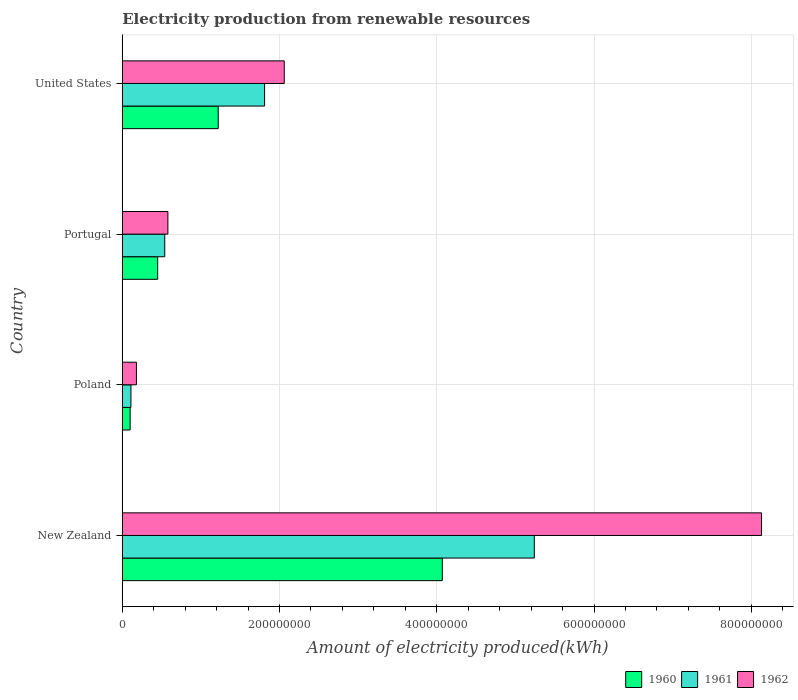How many different coloured bars are there?
Ensure brevity in your answer.  3. How many bars are there on the 4th tick from the bottom?
Your answer should be compact. 3. What is the label of the 3rd group of bars from the top?
Provide a short and direct response. Poland. What is the amount of electricity produced in 1961 in New Zealand?
Give a very brief answer. 5.24e+08. Across all countries, what is the maximum amount of electricity produced in 1960?
Your answer should be very brief. 4.07e+08. Across all countries, what is the minimum amount of electricity produced in 1962?
Offer a very short reply. 1.80e+07. In which country was the amount of electricity produced in 1961 maximum?
Offer a very short reply. New Zealand. What is the total amount of electricity produced in 1960 in the graph?
Provide a short and direct response. 5.84e+08. What is the difference between the amount of electricity produced in 1960 in New Zealand and that in United States?
Make the answer very short. 2.85e+08. What is the difference between the amount of electricity produced in 1962 in Poland and the amount of electricity produced in 1961 in United States?
Keep it short and to the point. -1.63e+08. What is the average amount of electricity produced in 1960 per country?
Make the answer very short. 1.46e+08. What is the difference between the amount of electricity produced in 1961 and amount of electricity produced in 1960 in Portugal?
Offer a terse response. 9.00e+06. What is the ratio of the amount of electricity produced in 1962 in Poland to that in Portugal?
Offer a terse response. 0.31. What is the difference between the highest and the second highest amount of electricity produced in 1962?
Provide a succinct answer. 6.07e+08. What is the difference between the highest and the lowest amount of electricity produced in 1962?
Your answer should be very brief. 7.95e+08. In how many countries, is the amount of electricity produced in 1960 greater than the average amount of electricity produced in 1960 taken over all countries?
Provide a short and direct response. 1. Is the sum of the amount of electricity produced in 1961 in New Zealand and Portugal greater than the maximum amount of electricity produced in 1960 across all countries?
Keep it short and to the point. Yes. What does the 3rd bar from the bottom in United States represents?
Give a very brief answer. 1962. Are all the bars in the graph horizontal?
Offer a terse response. Yes. Does the graph contain any zero values?
Offer a terse response. No. Where does the legend appear in the graph?
Offer a terse response. Bottom right. How many legend labels are there?
Keep it short and to the point. 3. What is the title of the graph?
Ensure brevity in your answer.  Electricity production from renewable resources. Does "2008" appear as one of the legend labels in the graph?
Keep it short and to the point. No. What is the label or title of the X-axis?
Your answer should be very brief. Amount of electricity produced(kWh). What is the label or title of the Y-axis?
Make the answer very short. Country. What is the Amount of electricity produced(kWh) of 1960 in New Zealand?
Your answer should be very brief. 4.07e+08. What is the Amount of electricity produced(kWh) in 1961 in New Zealand?
Provide a succinct answer. 5.24e+08. What is the Amount of electricity produced(kWh) of 1962 in New Zealand?
Offer a very short reply. 8.13e+08. What is the Amount of electricity produced(kWh) of 1961 in Poland?
Make the answer very short. 1.10e+07. What is the Amount of electricity produced(kWh) of 1962 in Poland?
Keep it short and to the point. 1.80e+07. What is the Amount of electricity produced(kWh) in 1960 in Portugal?
Provide a short and direct response. 4.50e+07. What is the Amount of electricity produced(kWh) of 1961 in Portugal?
Give a very brief answer. 5.40e+07. What is the Amount of electricity produced(kWh) in 1962 in Portugal?
Ensure brevity in your answer.  5.80e+07. What is the Amount of electricity produced(kWh) of 1960 in United States?
Your answer should be compact. 1.22e+08. What is the Amount of electricity produced(kWh) in 1961 in United States?
Give a very brief answer. 1.81e+08. What is the Amount of electricity produced(kWh) in 1962 in United States?
Offer a very short reply. 2.06e+08. Across all countries, what is the maximum Amount of electricity produced(kWh) in 1960?
Offer a very short reply. 4.07e+08. Across all countries, what is the maximum Amount of electricity produced(kWh) in 1961?
Your answer should be compact. 5.24e+08. Across all countries, what is the maximum Amount of electricity produced(kWh) of 1962?
Ensure brevity in your answer.  8.13e+08. Across all countries, what is the minimum Amount of electricity produced(kWh) of 1961?
Offer a very short reply. 1.10e+07. Across all countries, what is the minimum Amount of electricity produced(kWh) of 1962?
Offer a terse response. 1.80e+07. What is the total Amount of electricity produced(kWh) in 1960 in the graph?
Give a very brief answer. 5.84e+08. What is the total Amount of electricity produced(kWh) of 1961 in the graph?
Ensure brevity in your answer.  7.70e+08. What is the total Amount of electricity produced(kWh) of 1962 in the graph?
Ensure brevity in your answer.  1.10e+09. What is the difference between the Amount of electricity produced(kWh) of 1960 in New Zealand and that in Poland?
Your response must be concise. 3.97e+08. What is the difference between the Amount of electricity produced(kWh) of 1961 in New Zealand and that in Poland?
Your answer should be compact. 5.13e+08. What is the difference between the Amount of electricity produced(kWh) in 1962 in New Zealand and that in Poland?
Ensure brevity in your answer.  7.95e+08. What is the difference between the Amount of electricity produced(kWh) of 1960 in New Zealand and that in Portugal?
Offer a very short reply. 3.62e+08. What is the difference between the Amount of electricity produced(kWh) of 1961 in New Zealand and that in Portugal?
Give a very brief answer. 4.70e+08. What is the difference between the Amount of electricity produced(kWh) of 1962 in New Zealand and that in Portugal?
Make the answer very short. 7.55e+08. What is the difference between the Amount of electricity produced(kWh) in 1960 in New Zealand and that in United States?
Give a very brief answer. 2.85e+08. What is the difference between the Amount of electricity produced(kWh) of 1961 in New Zealand and that in United States?
Your answer should be very brief. 3.43e+08. What is the difference between the Amount of electricity produced(kWh) in 1962 in New Zealand and that in United States?
Keep it short and to the point. 6.07e+08. What is the difference between the Amount of electricity produced(kWh) of 1960 in Poland and that in Portugal?
Your answer should be compact. -3.50e+07. What is the difference between the Amount of electricity produced(kWh) in 1961 in Poland and that in Portugal?
Ensure brevity in your answer.  -4.30e+07. What is the difference between the Amount of electricity produced(kWh) in 1962 in Poland and that in Portugal?
Give a very brief answer. -4.00e+07. What is the difference between the Amount of electricity produced(kWh) in 1960 in Poland and that in United States?
Offer a terse response. -1.12e+08. What is the difference between the Amount of electricity produced(kWh) of 1961 in Poland and that in United States?
Offer a very short reply. -1.70e+08. What is the difference between the Amount of electricity produced(kWh) of 1962 in Poland and that in United States?
Ensure brevity in your answer.  -1.88e+08. What is the difference between the Amount of electricity produced(kWh) of 1960 in Portugal and that in United States?
Your response must be concise. -7.70e+07. What is the difference between the Amount of electricity produced(kWh) in 1961 in Portugal and that in United States?
Keep it short and to the point. -1.27e+08. What is the difference between the Amount of electricity produced(kWh) of 1962 in Portugal and that in United States?
Provide a succinct answer. -1.48e+08. What is the difference between the Amount of electricity produced(kWh) of 1960 in New Zealand and the Amount of electricity produced(kWh) of 1961 in Poland?
Ensure brevity in your answer.  3.96e+08. What is the difference between the Amount of electricity produced(kWh) of 1960 in New Zealand and the Amount of electricity produced(kWh) of 1962 in Poland?
Your answer should be compact. 3.89e+08. What is the difference between the Amount of electricity produced(kWh) of 1961 in New Zealand and the Amount of electricity produced(kWh) of 1962 in Poland?
Provide a short and direct response. 5.06e+08. What is the difference between the Amount of electricity produced(kWh) in 1960 in New Zealand and the Amount of electricity produced(kWh) in 1961 in Portugal?
Provide a short and direct response. 3.53e+08. What is the difference between the Amount of electricity produced(kWh) in 1960 in New Zealand and the Amount of electricity produced(kWh) in 1962 in Portugal?
Offer a very short reply. 3.49e+08. What is the difference between the Amount of electricity produced(kWh) in 1961 in New Zealand and the Amount of electricity produced(kWh) in 1962 in Portugal?
Provide a short and direct response. 4.66e+08. What is the difference between the Amount of electricity produced(kWh) in 1960 in New Zealand and the Amount of electricity produced(kWh) in 1961 in United States?
Give a very brief answer. 2.26e+08. What is the difference between the Amount of electricity produced(kWh) of 1960 in New Zealand and the Amount of electricity produced(kWh) of 1962 in United States?
Provide a succinct answer. 2.01e+08. What is the difference between the Amount of electricity produced(kWh) of 1961 in New Zealand and the Amount of electricity produced(kWh) of 1962 in United States?
Your answer should be very brief. 3.18e+08. What is the difference between the Amount of electricity produced(kWh) in 1960 in Poland and the Amount of electricity produced(kWh) in 1961 in Portugal?
Ensure brevity in your answer.  -4.40e+07. What is the difference between the Amount of electricity produced(kWh) in 1960 in Poland and the Amount of electricity produced(kWh) in 1962 in Portugal?
Your response must be concise. -4.80e+07. What is the difference between the Amount of electricity produced(kWh) in 1961 in Poland and the Amount of electricity produced(kWh) in 1962 in Portugal?
Offer a very short reply. -4.70e+07. What is the difference between the Amount of electricity produced(kWh) in 1960 in Poland and the Amount of electricity produced(kWh) in 1961 in United States?
Offer a terse response. -1.71e+08. What is the difference between the Amount of electricity produced(kWh) in 1960 in Poland and the Amount of electricity produced(kWh) in 1962 in United States?
Keep it short and to the point. -1.96e+08. What is the difference between the Amount of electricity produced(kWh) of 1961 in Poland and the Amount of electricity produced(kWh) of 1962 in United States?
Your response must be concise. -1.95e+08. What is the difference between the Amount of electricity produced(kWh) in 1960 in Portugal and the Amount of electricity produced(kWh) in 1961 in United States?
Make the answer very short. -1.36e+08. What is the difference between the Amount of electricity produced(kWh) in 1960 in Portugal and the Amount of electricity produced(kWh) in 1962 in United States?
Provide a succinct answer. -1.61e+08. What is the difference between the Amount of electricity produced(kWh) of 1961 in Portugal and the Amount of electricity produced(kWh) of 1962 in United States?
Your response must be concise. -1.52e+08. What is the average Amount of electricity produced(kWh) in 1960 per country?
Your answer should be compact. 1.46e+08. What is the average Amount of electricity produced(kWh) in 1961 per country?
Offer a terse response. 1.92e+08. What is the average Amount of electricity produced(kWh) in 1962 per country?
Your answer should be compact. 2.74e+08. What is the difference between the Amount of electricity produced(kWh) of 1960 and Amount of electricity produced(kWh) of 1961 in New Zealand?
Offer a terse response. -1.17e+08. What is the difference between the Amount of electricity produced(kWh) in 1960 and Amount of electricity produced(kWh) in 1962 in New Zealand?
Provide a short and direct response. -4.06e+08. What is the difference between the Amount of electricity produced(kWh) in 1961 and Amount of electricity produced(kWh) in 1962 in New Zealand?
Your response must be concise. -2.89e+08. What is the difference between the Amount of electricity produced(kWh) of 1960 and Amount of electricity produced(kWh) of 1961 in Poland?
Your answer should be compact. -1.00e+06. What is the difference between the Amount of electricity produced(kWh) of 1960 and Amount of electricity produced(kWh) of 1962 in Poland?
Your answer should be very brief. -8.00e+06. What is the difference between the Amount of electricity produced(kWh) in 1961 and Amount of electricity produced(kWh) in 1962 in Poland?
Make the answer very short. -7.00e+06. What is the difference between the Amount of electricity produced(kWh) in 1960 and Amount of electricity produced(kWh) in 1961 in Portugal?
Provide a short and direct response. -9.00e+06. What is the difference between the Amount of electricity produced(kWh) of 1960 and Amount of electricity produced(kWh) of 1962 in Portugal?
Your response must be concise. -1.30e+07. What is the difference between the Amount of electricity produced(kWh) in 1961 and Amount of electricity produced(kWh) in 1962 in Portugal?
Your answer should be very brief. -4.00e+06. What is the difference between the Amount of electricity produced(kWh) of 1960 and Amount of electricity produced(kWh) of 1961 in United States?
Offer a very short reply. -5.90e+07. What is the difference between the Amount of electricity produced(kWh) in 1960 and Amount of electricity produced(kWh) in 1962 in United States?
Offer a terse response. -8.40e+07. What is the difference between the Amount of electricity produced(kWh) of 1961 and Amount of electricity produced(kWh) of 1962 in United States?
Your response must be concise. -2.50e+07. What is the ratio of the Amount of electricity produced(kWh) of 1960 in New Zealand to that in Poland?
Your answer should be very brief. 40.7. What is the ratio of the Amount of electricity produced(kWh) of 1961 in New Zealand to that in Poland?
Offer a terse response. 47.64. What is the ratio of the Amount of electricity produced(kWh) in 1962 in New Zealand to that in Poland?
Offer a terse response. 45.17. What is the ratio of the Amount of electricity produced(kWh) in 1960 in New Zealand to that in Portugal?
Keep it short and to the point. 9.04. What is the ratio of the Amount of electricity produced(kWh) in 1961 in New Zealand to that in Portugal?
Provide a short and direct response. 9.7. What is the ratio of the Amount of electricity produced(kWh) of 1962 in New Zealand to that in Portugal?
Offer a very short reply. 14.02. What is the ratio of the Amount of electricity produced(kWh) in 1960 in New Zealand to that in United States?
Offer a very short reply. 3.34. What is the ratio of the Amount of electricity produced(kWh) in 1961 in New Zealand to that in United States?
Your answer should be very brief. 2.9. What is the ratio of the Amount of electricity produced(kWh) of 1962 in New Zealand to that in United States?
Your response must be concise. 3.95. What is the ratio of the Amount of electricity produced(kWh) of 1960 in Poland to that in Portugal?
Your answer should be very brief. 0.22. What is the ratio of the Amount of electricity produced(kWh) in 1961 in Poland to that in Portugal?
Offer a very short reply. 0.2. What is the ratio of the Amount of electricity produced(kWh) of 1962 in Poland to that in Portugal?
Ensure brevity in your answer.  0.31. What is the ratio of the Amount of electricity produced(kWh) in 1960 in Poland to that in United States?
Offer a terse response. 0.08. What is the ratio of the Amount of electricity produced(kWh) of 1961 in Poland to that in United States?
Provide a succinct answer. 0.06. What is the ratio of the Amount of electricity produced(kWh) of 1962 in Poland to that in United States?
Your response must be concise. 0.09. What is the ratio of the Amount of electricity produced(kWh) in 1960 in Portugal to that in United States?
Offer a terse response. 0.37. What is the ratio of the Amount of electricity produced(kWh) in 1961 in Portugal to that in United States?
Offer a very short reply. 0.3. What is the ratio of the Amount of electricity produced(kWh) in 1962 in Portugal to that in United States?
Give a very brief answer. 0.28. What is the difference between the highest and the second highest Amount of electricity produced(kWh) in 1960?
Ensure brevity in your answer.  2.85e+08. What is the difference between the highest and the second highest Amount of electricity produced(kWh) in 1961?
Provide a succinct answer. 3.43e+08. What is the difference between the highest and the second highest Amount of electricity produced(kWh) of 1962?
Offer a very short reply. 6.07e+08. What is the difference between the highest and the lowest Amount of electricity produced(kWh) of 1960?
Your response must be concise. 3.97e+08. What is the difference between the highest and the lowest Amount of electricity produced(kWh) in 1961?
Your response must be concise. 5.13e+08. What is the difference between the highest and the lowest Amount of electricity produced(kWh) in 1962?
Ensure brevity in your answer.  7.95e+08. 